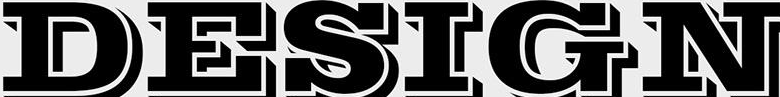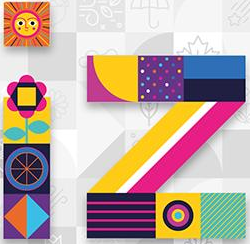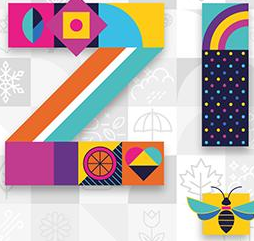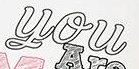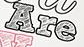What text appears in these images from left to right, separated by a semicolon? DESIGN; iz; iz; You; Are 